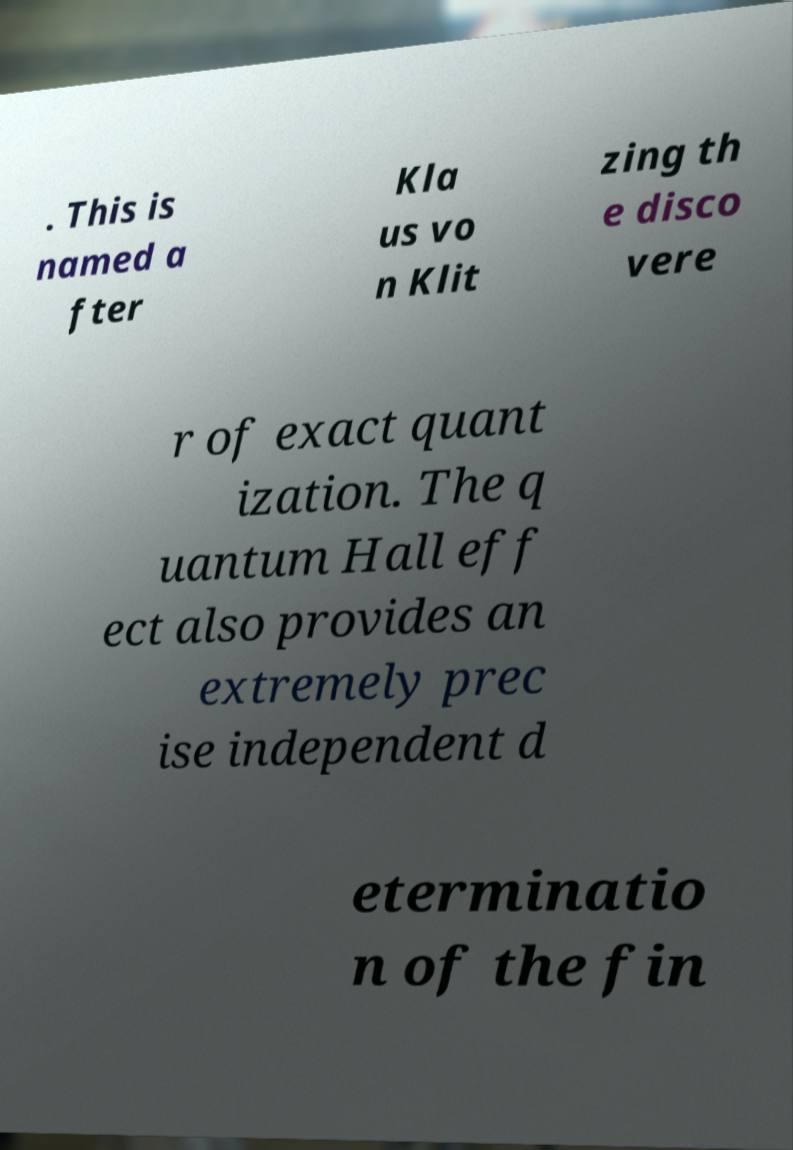There's text embedded in this image that I need extracted. Can you transcribe it verbatim? . This is named a fter Kla us vo n Klit zing th e disco vere r of exact quant ization. The q uantum Hall eff ect also provides an extremely prec ise independent d eterminatio n of the fin 